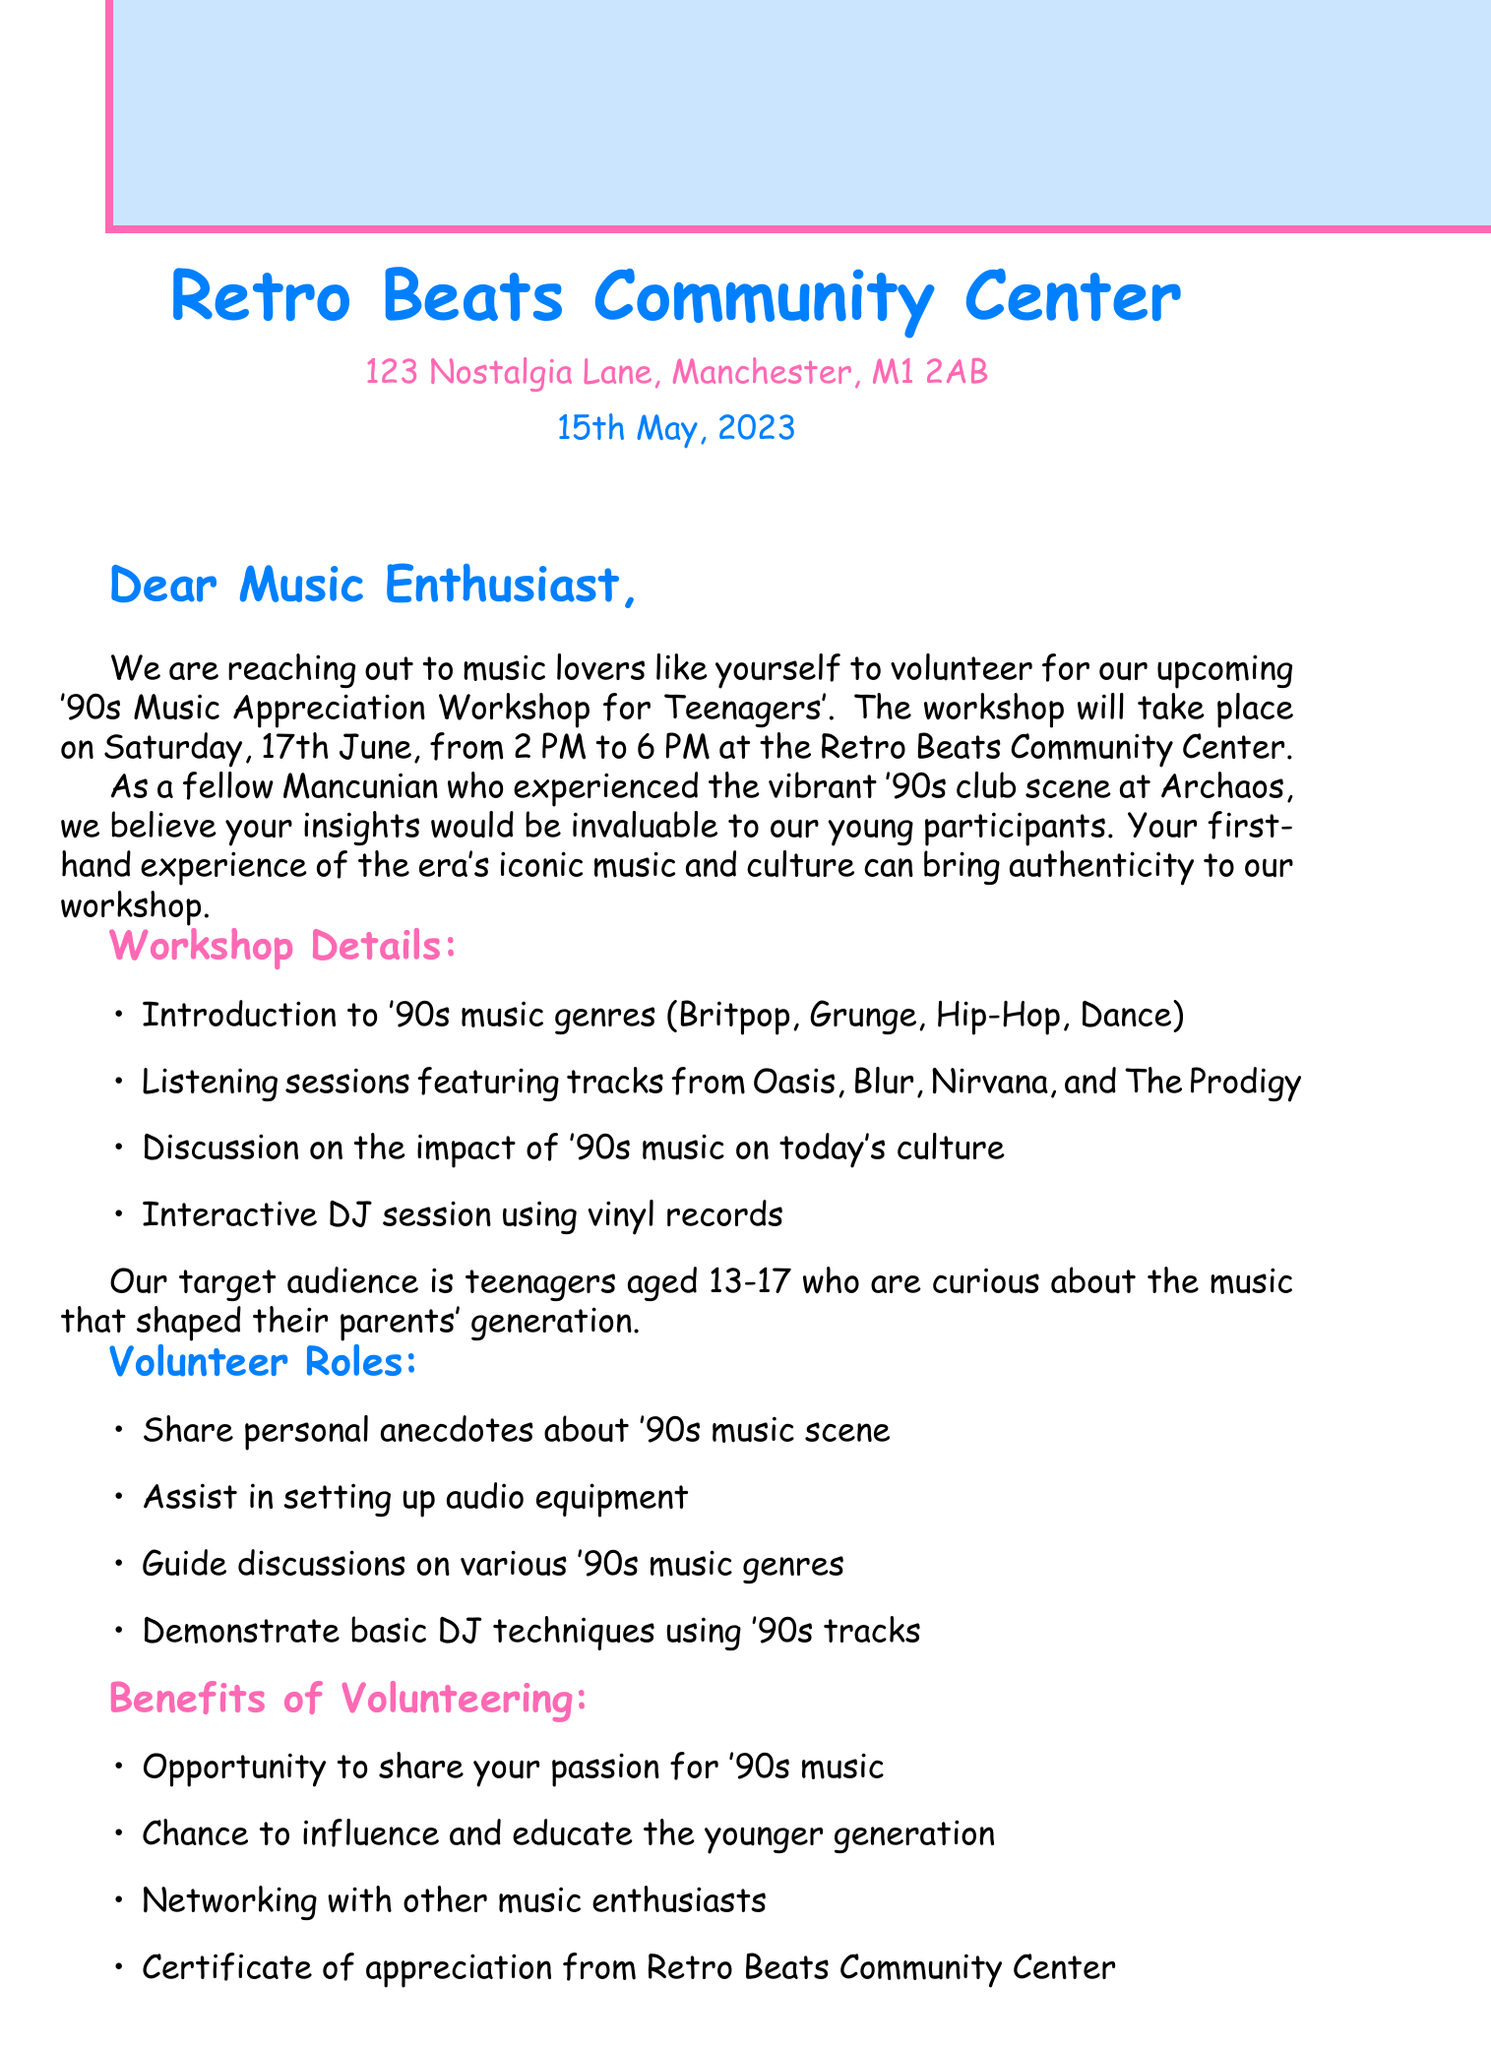What is the date of the workshop? The workshop is scheduled for Saturday, 17th June, which is mentioned in the event details.
Answer: 17th June What is the target audience age for the workshop? The workshop is aimed at teenagers aged 13-17, as stated in the workshop details.
Answer: 13-17 Who should be contacted for volunteering? The letter specifies that Sarah Thompson is the contact person for those interested in volunteering.
Answer: Sarah Thompson What are two recommended activities in the workshop? The document lists multiple activities, including listening sessions and a discussion on the impact of '90s music.
Answer: Listening sessions, Discussion What is the address of the Retro Beats Community Center? The address is provided in the letter header, detailing the location of the community center.
Answer: 123 Nostalgia Lane, Manchester, M1 2AB What is one of the benefits of volunteering mentioned? The letter lists several benefits, such as networking with other music enthusiasts.
Answer: Networking with other music enthusiasts What time does the workshop start? The start time of the workshop is provided in the introduction section of the letter.
Answer: 2 PM What personal experiences are volunteers encouraged to share? Volunteers are asked to share personal anecdotes about the '90s music scene, as noted in the volunteer roles.
Answer: Personal anecdotes about '90s music scene 